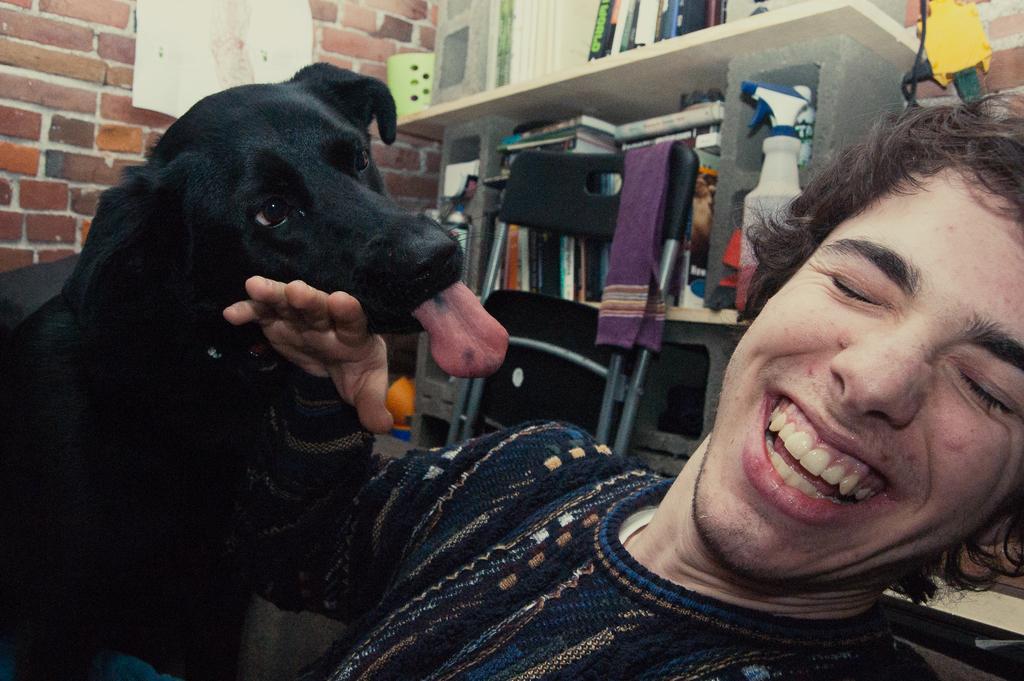Please provide a concise description of this image. In this picture there is a man smiling and there's a dog beside him. In the background there are books kept in the shelf 